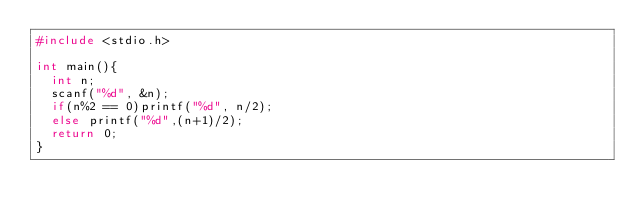<code> <loc_0><loc_0><loc_500><loc_500><_C++_>#include <stdio.h>

int main(){
  int n;
  scanf("%d", &n);
  if(n%2 == 0)printf("%d", n/2);
  else printf("%d",(n+1)/2);
  return 0;
}</code> 